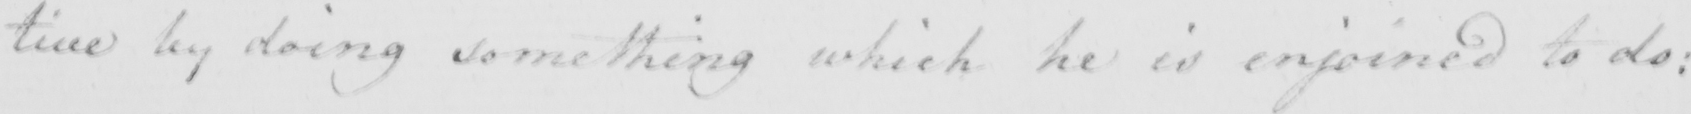Please provide the text content of this handwritten line. : tive by doing something which he is enjoined to do : 